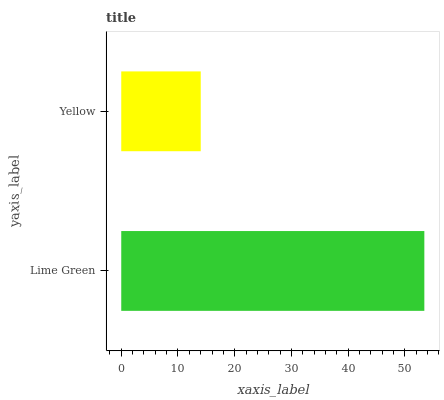Is Yellow the minimum?
Answer yes or no. Yes. Is Lime Green the maximum?
Answer yes or no. Yes. Is Yellow the maximum?
Answer yes or no. No. Is Lime Green greater than Yellow?
Answer yes or no. Yes. Is Yellow less than Lime Green?
Answer yes or no. Yes. Is Yellow greater than Lime Green?
Answer yes or no. No. Is Lime Green less than Yellow?
Answer yes or no. No. Is Lime Green the high median?
Answer yes or no. Yes. Is Yellow the low median?
Answer yes or no. Yes. Is Yellow the high median?
Answer yes or no. No. Is Lime Green the low median?
Answer yes or no. No. 